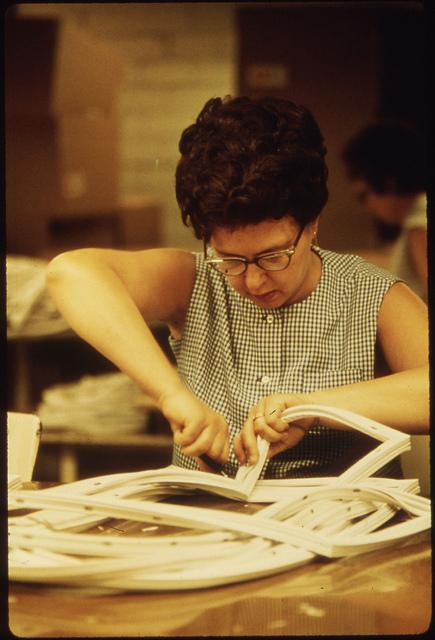What are the colors of the women's shirt?
Be succinct. Black and white. What is she holding?
Short answer required. Knife. What is the woman wearing on her face?
Keep it brief. Glasses. 